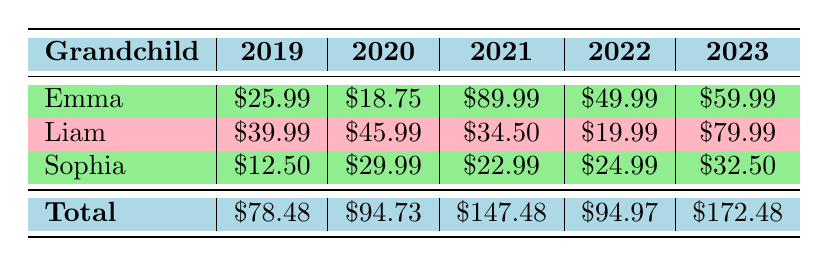What was the total gift expense for Liam across all five years? To find this, sum all the expenses for Liam from 2019 to 2023: (39.99 + 45.99 + 34.50 + 19.99 + 79.99) = 220.46
Answer: 220.46 Which year did Emma receive the most expensive gift? Looking at the table, the expenses for Emma are 25.99 in 2019, 18.75 in 2020, 89.99 in 2021, 49.99 in 2022, and 59.99 in 2023. The highest amount is 89.99 in 2021.
Answer: 2021 Did Sophia receive more than $30 in gift expenses in 2023? According to the table, Sophia's expense for 2023 is 32.50. Since 32.50 is greater than 30, the answer is yes.
Answer: Yes What is the average expense for gifts received by Emma over the five years? To find the average, add Emma's expenses: (25.99 + 18.75 + 89.99 + 49.99 + 59.99) = 244.71. Divide that total by 5 (the number of years), which equals 48.942.
Answer: 48.94 What is the total expense for all grandchildren in 2020? The total expense for each grandchild in 2020 is: Emma: 18.75, Liam: 45.99, and Sophia: 29.99. Adding these up gives: (18.75 + 45.99 + 29.99) = 94.73.
Answer: 94.73 